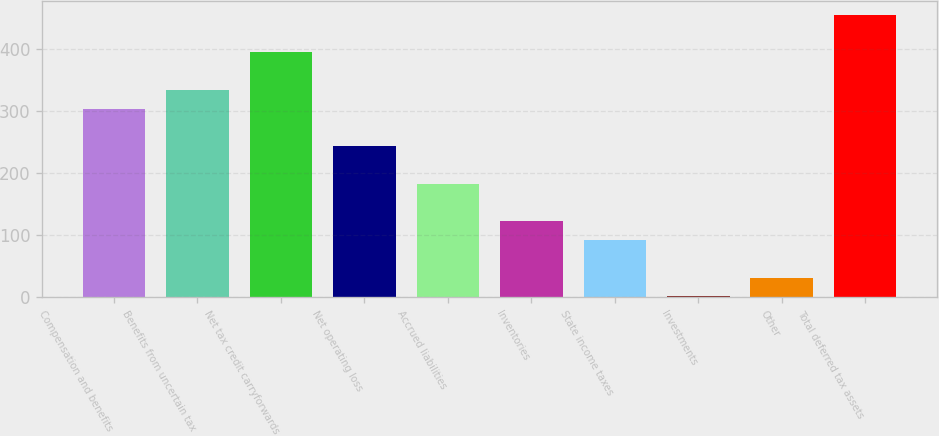Convert chart to OTSL. <chart><loc_0><loc_0><loc_500><loc_500><bar_chart><fcel>Compensation and benefits<fcel>Benefits from uncertain tax<fcel>Net tax credit carryforwards<fcel>Net operating loss<fcel>Accrued liabilities<fcel>Inventories<fcel>State income taxes<fcel>Investments<fcel>Other<fcel>Total deferred tax assets<nl><fcel>304.5<fcel>334.79<fcel>395.37<fcel>243.92<fcel>183.34<fcel>122.76<fcel>92.47<fcel>1.6<fcel>31.89<fcel>455.95<nl></chart> 